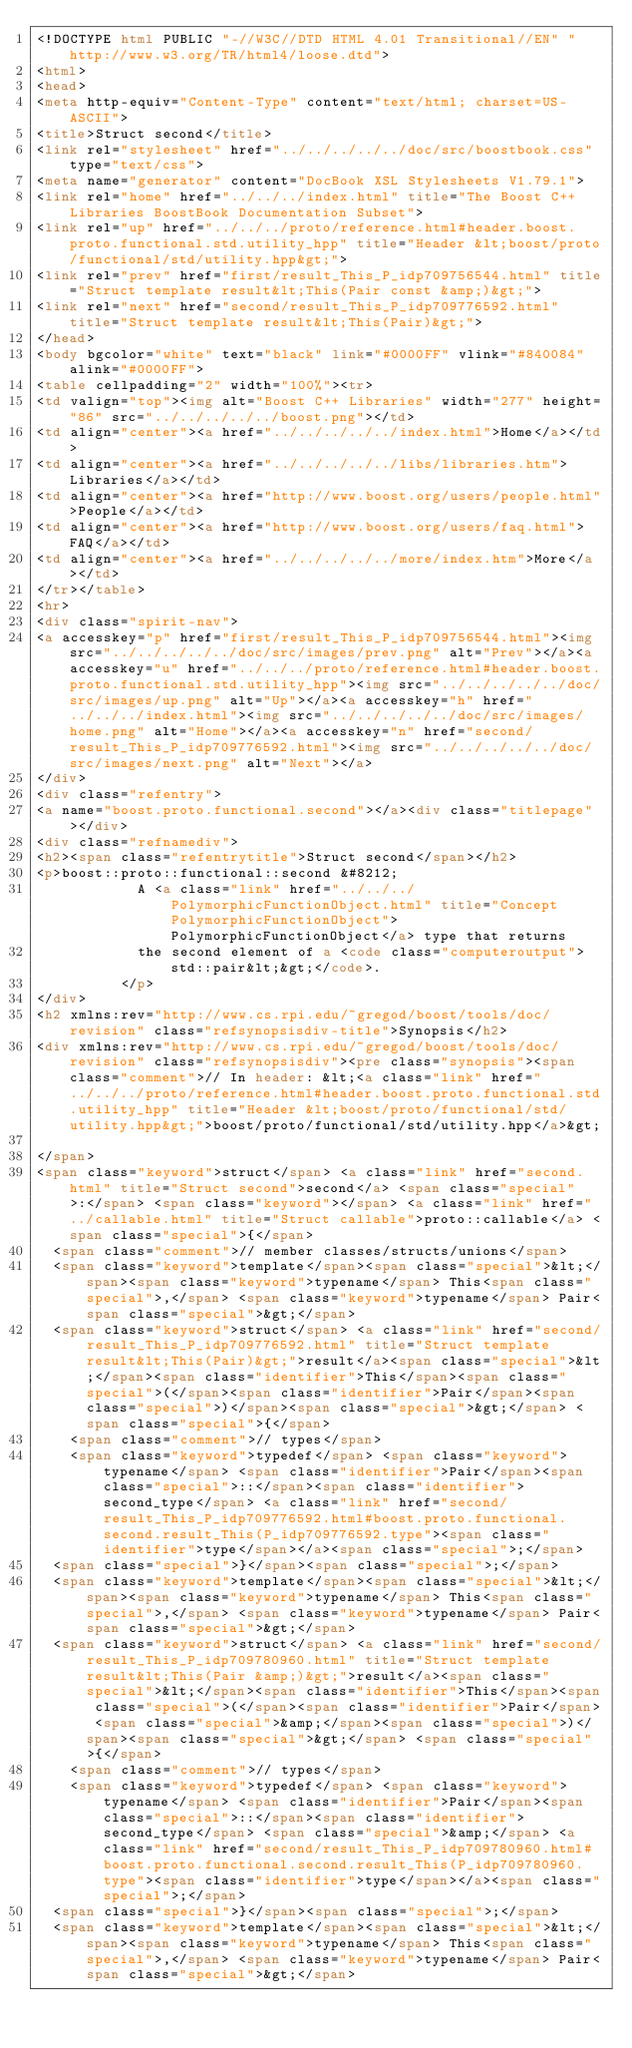Convert code to text. <code><loc_0><loc_0><loc_500><loc_500><_HTML_><!DOCTYPE html PUBLIC "-//W3C//DTD HTML 4.01 Transitional//EN" "http://www.w3.org/TR/html4/loose.dtd">
<html>
<head>
<meta http-equiv="Content-Type" content="text/html; charset=US-ASCII">
<title>Struct second</title>
<link rel="stylesheet" href="../../../../../doc/src/boostbook.css" type="text/css">
<meta name="generator" content="DocBook XSL Stylesheets V1.79.1">
<link rel="home" href="../../../index.html" title="The Boost C++ Libraries BoostBook Documentation Subset">
<link rel="up" href="../../../proto/reference.html#header.boost.proto.functional.std.utility_hpp" title="Header &lt;boost/proto/functional/std/utility.hpp&gt;">
<link rel="prev" href="first/result_This_P_idp709756544.html" title="Struct template result&lt;This(Pair const &amp;)&gt;">
<link rel="next" href="second/result_This_P_idp709776592.html" title="Struct template result&lt;This(Pair)&gt;">
</head>
<body bgcolor="white" text="black" link="#0000FF" vlink="#840084" alink="#0000FF">
<table cellpadding="2" width="100%"><tr>
<td valign="top"><img alt="Boost C++ Libraries" width="277" height="86" src="../../../../../boost.png"></td>
<td align="center"><a href="../../../../../index.html">Home</a></td>
<td align="center"><a href="../../../../../libs/libraries.htm">Libraries</a></td>
<td align="center"><a href="http://www.boost.org/users/people.html">People</a></td>
<td align="center"><a href="http://www.boost.org/users/faq.html">FAQ</a></td>
<td align="center"><a href="../../../../../more/index.htm">More</a></td>
</tr></table>
<hr>
<div class="spirit-nav">
<a accesskey="p" href="first/result_This_P_idp709756544.html"><img src="../../../../../doc/src/images/prev.png" alt="Prev"></a><a accesskey="u" href="../../../proto/reference.html#header.boost.proto.functional.std.utility_hpp"><img src="../../../../../doc/src/images/up.png" alt="Up"></a><a accesskey="h" href="../../../index.html"><img src="../../../../../doc/src/images/home.png" alt="Home"></a><a accesskey="n" href="second/result_This_P_idp709776592.html"><img src="../../../../../doc/src/images/next.png" alt="Next"></a>
</div>
<div class="refentry">
<a name="boost.proto.functional.second"></a><div class="titlepage"></div>
<div class="refnamediv">
<h2><span class="refentrytitle">Struct second</span></h2>
<p>boost::proto::functional::second &#8212; 
            A <a class="link" href="../../../PolymorphicFunctionObject.html" title="Concept PolymorphicFunctionObject">PolymorphicFunctionObject</a> type that returns
            the second element of a <code class="computeroutput">std::pair&lt;&gt;</code>.
          </p>
</div>
<h2 xmlns:rev="http://www.cs.rpi.edu/~gregod/boost/tools/doc/revision" class="refsynopsisdiv-title">Synopsis</h2>
<div xmlns:rev="http://www.cs.rpi.edu/~gregod/boost/tools/doc/revision" class="refsynopsisdiv"><pre class="synopsis"><span class="comment">// In header: &lt;<a class="link" href="../../../proto/reference.html#header.boost.proto.functional.std.utility_hpp" title="Header &lt;boost/proto/functional/std/utility.hpp&gt;">boost/proto/functional/std/utility.hpp</a>&gt;

</span>
<span class="keyword">struct</span> <a class="link" href="second.html" title="Struct second">second</a> <span class="special">:</span> <span class="keyword"></span> <a class="link" href="../callable.html" title="Struct callable">proto::callable</a> <span class="special">{</span>
  <span class="comment">// member classes/structs/unions</span>
  <span class="keyword">template</span><span class="special">&lt;</span><span class="keyword">typename</span> This<span class="special">,</span> <span class="keyword">typename</span> Pair<span class="special">&gt;</span> 
  <span class="keyword">struct</span> <a class="link" href="second/result_This_P_idp709776592.html" title="Struct template result&lt;This(Pair)&gt;">result</a><span class="special">&lt;</span><span class="identifier">This</span><span class="special">(</span><span class="identifier">Pair</span><span class="special">)</span><span class="special">&gt;</span> <span class="special">{</span>
    <span class="comment">// types</span>
    <span class="keyword">typedef</span> <span class="keyword">typename</span> <span class="identifier">Pair</span><span class="special">::</span><span class="identifier">second_type</span> <a class="link" href="second/result_This_P_idp709776592.html#boost.proto.functional.second.result_This(P_idp709776592.type"><span class="identifier">type</span></a><span class="special">;</span>
  <span class="special">}</span><span class="special">;</span>
  <span class="keyword">template</span><span class="special">&lt;</span><span class="keyword">typename</span> This<span class="special">,</span> <span class="keyword">typename</span> Pair<span class="special">&gt;</span> 
  <span class="keyword">struct</span> <a class="link" href="second/result_This_P_idp709780960.html" title="Struct template result&lt;This(Pair &amp;)&gt;">result</a><span class="special">&lt;</span><span class="identifier">This</span><span class="special">(</span><span class="identifier">Pair</span> <span class="special">&amp;</span><span class="special">)</span><span class="special">&gt;</span> <span class="special">{</span>
    <span class="comment">// types</span>
    <span class="keyword">typedef</span> <span class="keyword">typename</span> <span class="identifier">Pair</span><span class="special">::</span><span class="identifier">second_type</span> <span class="special">&amp;</span> <a class="link" href="second/result_This_P_idp709780960.html#boost.proto.functional.second.result_This(P_idp709780960.type"><span class="identifier">type</span></a><span class="special">;</span>
  <span class="special">}</span><span class="special">;</span>
  <span class="keyword">template</span><span class="special">&lt;</span><span class="keyword">typename</span> This<span class="special">,</span> <span class="keyword">typename</span> Pair<span class="special">&gt;</span> </code> 